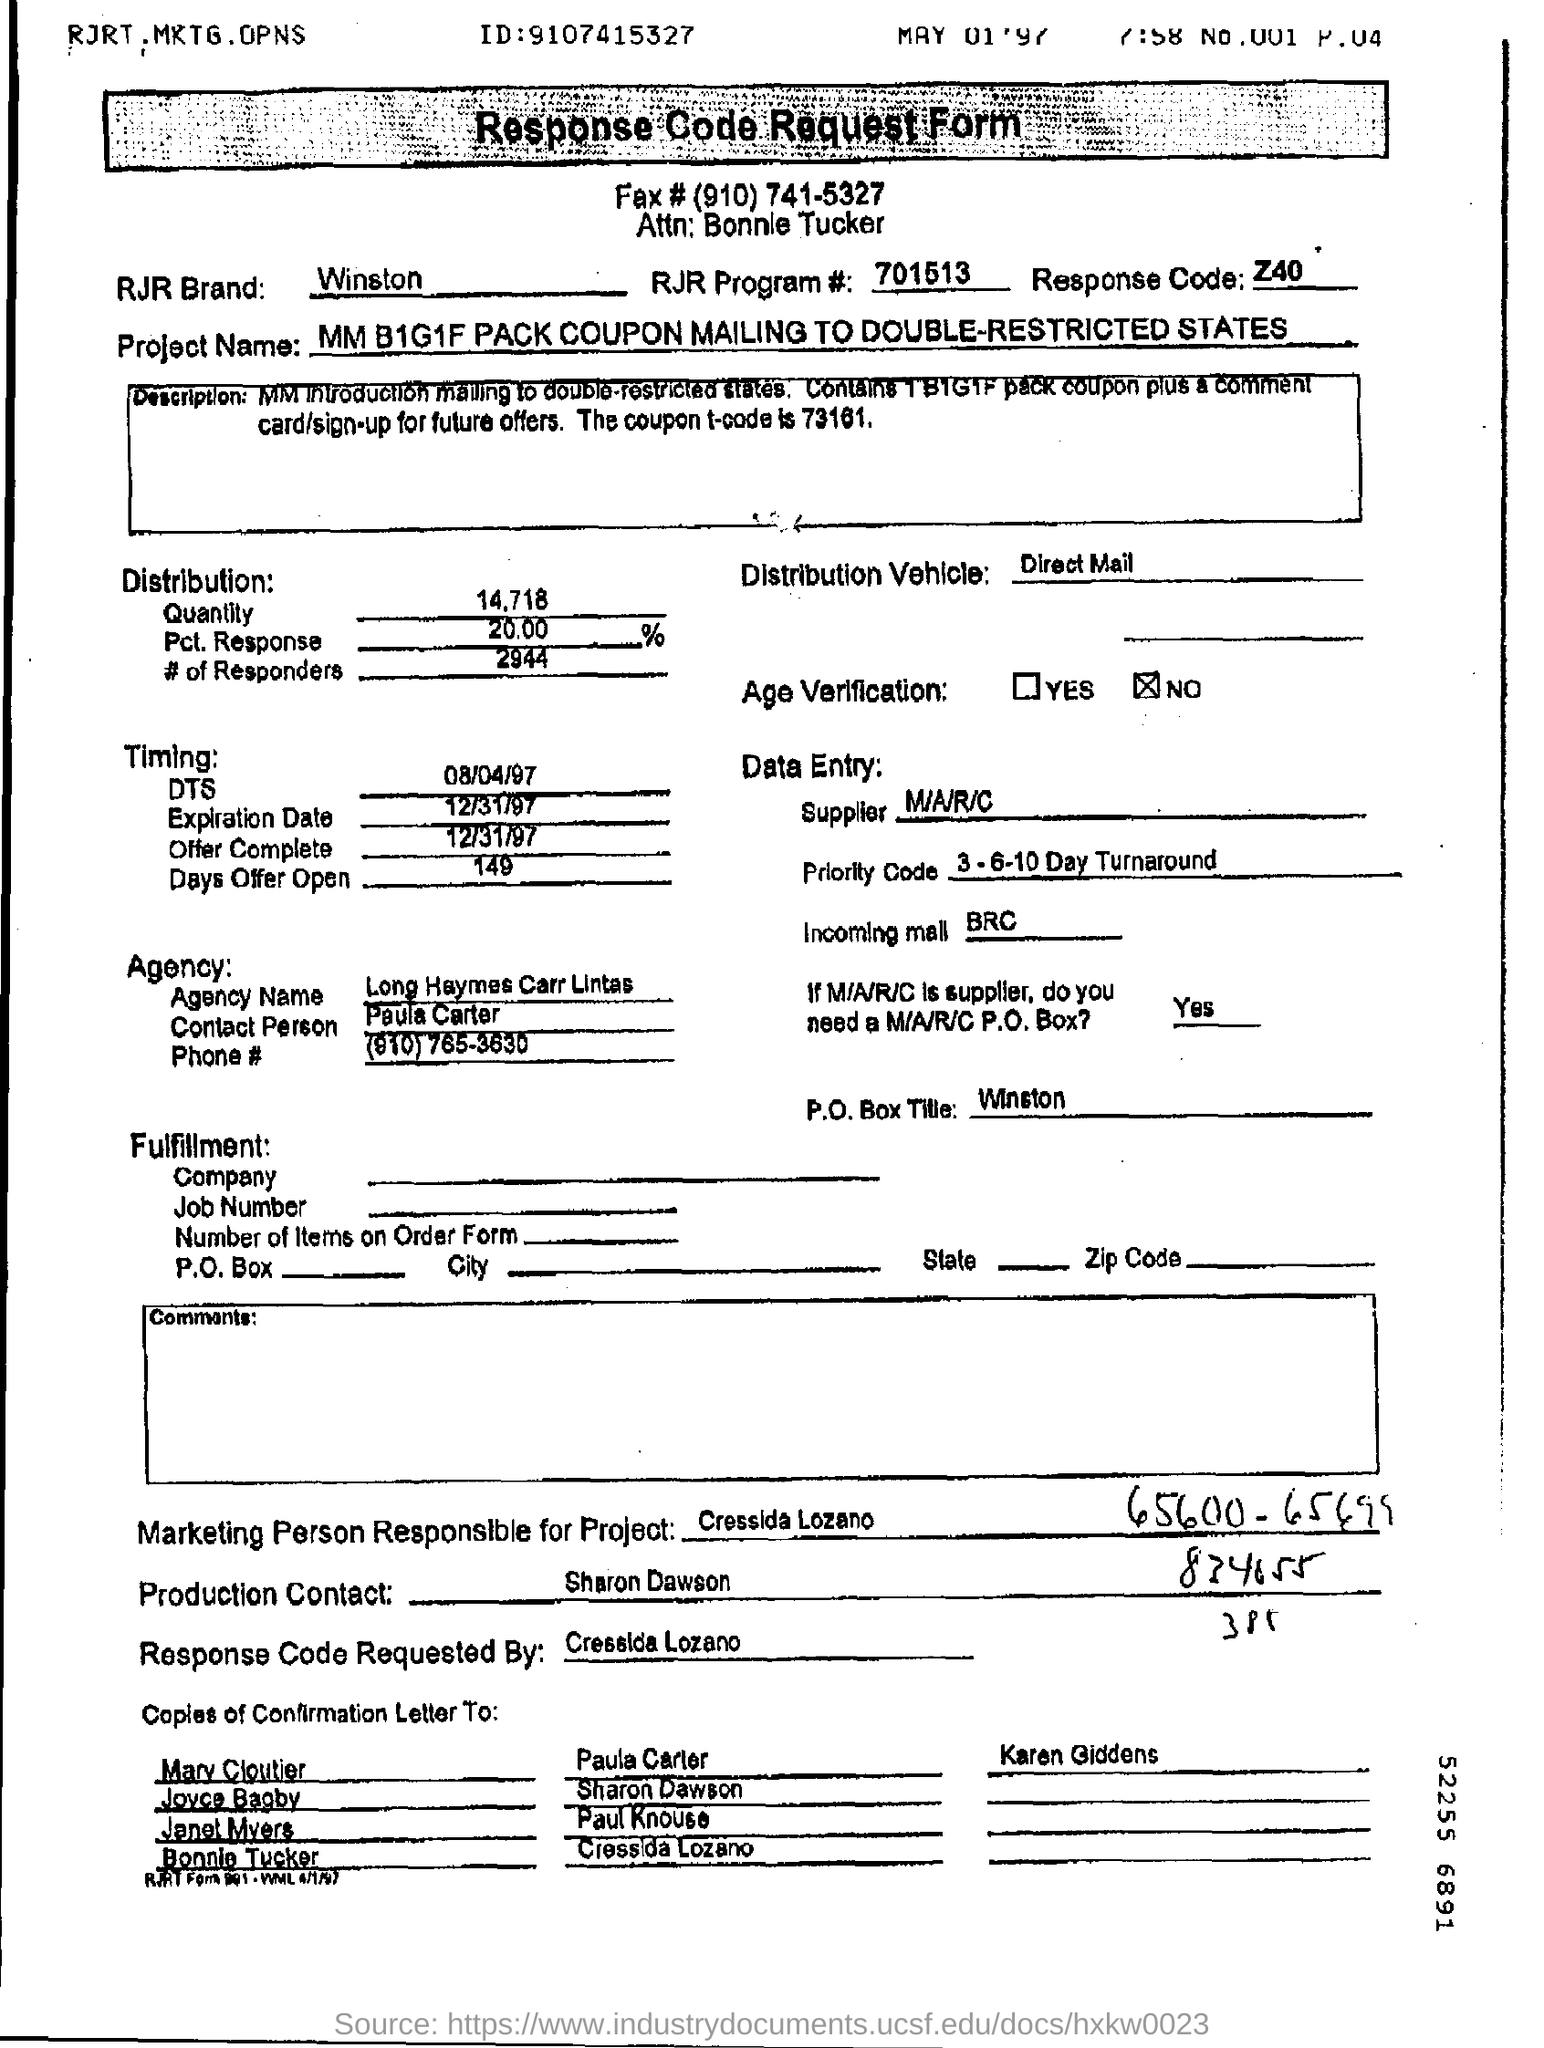Can you describe what this document is about? The document appears to be a 'Response Code Request Form' for a marketing project involving the mailing of coupons. The project is named MM B1G1F PACK COUPON MAILING TO DOUBLE-RESTRICTED STATES, which suggests that it involves a buy-one-get-one-free pack coupon offer, limited to certain states. 